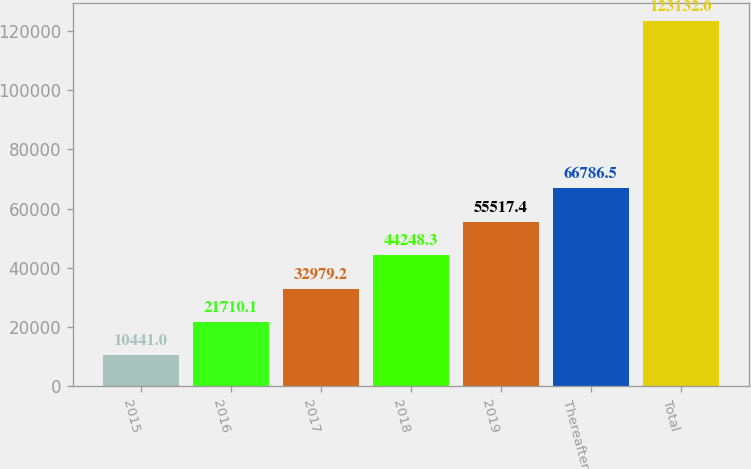Convert chart. <chart><loc_0><loc_0><loc_500><loc_500><bar_chart><fcel>2015<fcel>2016<fcel>2017<fcel>2018<fcel>2019<fcel>Thereafter<fcel>Total<nl><fcel>10441<fcel>21710.1<fcel>32979.2<fcel>44248.3<fcel>55517.4<fcel>66786.5<fcel>123132<nl></chart> 